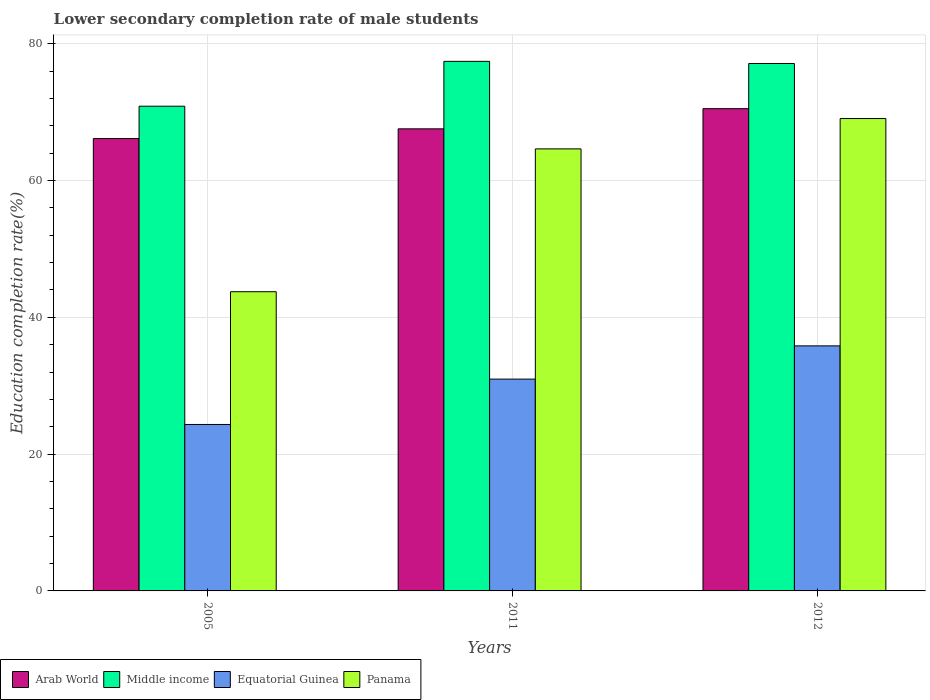How many different coloured bars are there?
Your answer should be very brief. 4. Are the number of bars on each tick of the X-axis equal?
Offer a very short reply. Yes. How many bars are there on the 2nd tick from the left?
Your answer should be very brief. 4. How many bars are there on the 3rd tick from the right?
Make the answer very short. 4. What is the label of the 2nd group of bars from the left?
Your answer should be very brief. 2011. What is the lower secondary completion rate of male students in Equatorial Guinea in 2012?
Provide a short and direct response. 35.83. Across all years, what is the maximum lower secondary completion rate of male students in Arab World?
Your response must be concise. 70.51. Across all years, what is the minimum lower secondary completion rate of male students in Panama?
Your response must be concise. 43.74. In which year was the lower secondary completion rate of male students in Arab World maximum?
Your answer should be compact. 2012. What is the total lower secondary completion rate of male students in Panama in the graph?
Keep it short and to the point. 177.43. What is the difference between the lower secondary completion rate of male students in Equatorial Guinea in 2005 and that in 2012?
Offer a terse response. -11.49. What is the difference between the lower secondary completion rate of male students in Equatorial Guinea in 2011 and the lower secondary completion rate of male students in Middle income in 2012?
Give a very brief answer. -46.14. What is the average lower secondary completion rate of male students in Arab World per year?
Provide a succinct answer. 68.07. In the year 2005, what is the difference between the lower secondary completion rate of male students in Middle income and lower secondary completion rate of male students in Arab World?
Provide a short and direct response. 4.73. What is the ratio of the lower secondary completion rate of male students in Arab World in 2005 to that in 2011?
Keep it short and to the point. 0.98. Is the lower secondary completion rate of male students in Middle income in 2011 less than that in 2012?
Provide a short and direct response. No. What is the difference between the highest and the second highest lower secondary completion rate of male students in Panama?
Offer a very short reply. 4.44. What is the difference between the highest and the lowest lower secondary completion rate of male students in Middle income?
Offer a very short reply. 6.56. In how many years, is the lower secondary completion rate of male students in Middle income greater than the average lower secondary completion rate of male students in Middle income taken over all years?
Provide a short and direct response. 2. Is the sum of the lower secondary completion rate of male students in Equatorial Guinea in 2011 and 2012 greater than the maximum lower secondary completion rate of male students in Middle income across all years?
Keep it short and to the point. No. Is it the case that in every year, the sum of the lower secondary completion rate of male students in Equatorial Guinea and lower secondary completion rate of male students in Panama is greater than the sum of lower secondary completion rate of male students in Middle income and lower secondary completion rate of male students in Arab World?
Your response must be concise. No. What does the 1st bar from the left in 2011 represents?
Make the answer very short. Arab World. What does the 3rd bar from the right in 2012 represents?
Offer a very short reply. Middle income. Is it the case that in every year, the sum of the lower secondary completion rate of male students in Middle income and lower secondary completion rate of male students in Equatorial Guinea is greater than the lower secondary completion rate of male students in Panama?
Your answer should be very brief. Yes. Are the values on the major ticks of Y-axis written in scientific E-notation?
Ensure brevity in your answer.  No. Does the graph contain grids?
Make the answer very short. Yes. Where does the legend appear in the graph?
Ensure brevity in your answer.  Bottom left. How many legend labels are there?
Make the answer very short. 4. What is the title of the graph?
Give a very brief answer. Lower secondary completion rate of male students. What is the label or title of the X-axis?
Your answer should be compact. Years. What is the label or title of the Y-axis?
Ensure brevity in your answer.  Education completion rate(%). What is the Education completion rate(%) in Arab World in 2005?
Ensure brevity in your answer.  66.14. What is the Education completion rate(%) in Middle income in 2005?
Your answer should be compact. 70.86. What is the Education completion rate(%) in Equatorial Guinea in 2005?
Ensure brevity in your answer.  24.33. What is the Education completion rate(%) of Panama in 2005?
Provide a succinct answer. 43.74. What is the Education completion rate(%) of Arab World in 2011?
Your answer should be compact. 67.56. What is the Education completion rate(%) in Middle income in 2011?
Give a very brief answer. 77.42. What is the Education completion rate(%) of Equatorial Guinea in 2011?
Keep it short and to the point. 30.97. What is the Education completion rate(%) in Panama in 2011?
Make the answer very short. 64.63. What is the Education completion rate(%) of Arab World in 2012?
Ensure brevity in your answer.  70.51. What is the Education completion rate(%) in Middle income in 2012?
Offer a very short reply. 77.11. What is the Education completion rate(%) of Equatorial Guinea in 2012?
Your answer should be very brief. 35.83. What is the Education completion rate(%) in Panama in 2012?
Ensure brevity in your answer.  69.06. Across all years, what is the maximum Education completion rate(%) of Arab World?
Your answer should be very brief. 70.51. Across all years, what is the maximum Education completion rate(%) in Middle income?
Ensure brevity in your answer.  77.42. Across all years, what is the maximum Education completion rate(%) in Equatorial Guinea?
Your answer should be very brief. 35.83. Across all years, what is the maximum Education completion rate(%) in Panama?
Offer a very short reply. 69.06. Across all years, what is the minimum Education completion rate(%) in Arab World?
Your answer should be very brief. 66.14. Across all years, what is the minimum Education completion rate(%) of Middle income?
Your answer should be compact. 70.86. Across all years, what is the minimum Education completion rate(%) in Equatorial Guinea?
Give a very brief answer. 24.33. Across all years, what is the minimum Education completion rate(%) of Panama?
Your response must be concise. 43.74. What is the total Education completion rate(%) of Arab World in the graph?
Ensure brevity in your answer.  204.2. What is the total Education completion rate(%) of Middle income in the graph?
Offer a very short reply. 225.4. What is the total Education completion rate(%) in Equatorial Guinea in the graph?
Provide a succinct answer. 91.13. What is the total Education completion rate(%) in Panama in the graph?
Provide a short and direct response. 177.43. What is the difference between the Education completion rate(%) in Arab World in 2005 and that in 2011?
Offer a very short reply. -1.42. What is the difference between the Education completion rate(%) of Middle income in 2005 and that in 2011?
Offer a very short reply. -6.56. What is the difference between the Education completion rate(%) in Equatorial Guinea in 2005 and that in 2011?
Make the answer very short. -6.63. What is the difference between the Education completion rate(%) in Panama in 2005 and that in 2011?
Ensure brevity in your answer.  -20.88. What is the difference between the Education completion rate(%) in Arab World in 2005 and that in 2012?
Provide a short and direct response. -4.37. What is the difference between the Education completion rate(%) in Middle income in 2005 and that in 2012?
Offer a very short reply. -6.25. What is the difference between the Education completion rate(%) in Equatorial Guinea in 2005 and that in 2012?
Offer a very short reply. -11.49. What is the difference between the Education completion rate(%) in Panama in 2005 and that in 2012?
Provide a short and direct response. -25.32. What is the difference between the Education completion rate(%) in Arab World in 2011 and that in 2012?
Keep it short and to the point. -2.95. What is the difference between the Education completion rate(%) of Middle income in 2011 and that in 2012?
Your response must be concise. 0.31. What is the difference between the Education completion rate(%) in Equatorial Guinea in 2011 and that in 2012?
Ensure brevity in your answer.  -4.86. What is the difference between the Education completion rate(%) in Panama in 2011 and that in 2012?
Provide a short and direct response. -4.44. What is the difference between the Education completion rate(%) of Arab World in 2005 and the Education completion rate(%) of Middle income in 2011?
Offer a very short reply. -11.28. What is the difference between the Education completion rate(%) of Arab World in 2005 and the Education completion rate(%) of Equatorial Guinea in 2011?
Provide a short and direct response. 35.17. What is the difference between the Education completion rate(%) in Arab World in 2005 and the Education completion rate(%) in Panama in 2011?
Ensure brevity in your answer.  1.51. What is the difference between the Education completion rate(%) in Middle income in 2005 and the Education completion rate(%) in Equatorial Guinea in 2011?
Offer a very short reply. 39.9. What is the difference between the Education completion rate(%) in Middle income in 2005 and the Education completion rate(%) in Panama in 2011?
Ensure brevity in your answer.  6.24. What is the difference between the Education completion rate(%) in Equatorial Guinea in 2005 and the Education completion rate(%) in Panama in 2011?
Keep it short and to the point. -40.29. What is the difference between the Education completion rate(%) in Arab World in 2005 and the Education completion rate(%) in Middle income in 2012?
Keep it short and to the point. -10.97. What is the difference between the Education completion rate(%) of Arab World in 2005 and the Education completion rate(%) of Equatorial Guinea in 2012?
Give a very brief answer. 30.31. What is the difference between the Education completion rate(%) in Arab World in 2005 and the Education completion rate(%) in Panama in 2012?
Give a very brief answer. -2.92. What is the difference between the Education completion rate(%) in Middle income in 2005 and the Education completion rate(%) in Equatorial Guinea in 2012?
Your answer should be very brief. 35.04. What is the difference between the Education completion rate(%) of Middle income in 2005 and the Education completion rate(%) of Panama in 2012?
Give a very brief answer. 1.8. What is the difference between the Education completion rate(%) of Equatorial Guinea in 2005 and the Education completion rate(%) of Panama in 2012?
Provide a succinct answer. -44.73. What is the difference between the Education completion rate(%) of Arab World in 2011 and the Education completion rate(%) of Middle income in 2012?
Your response must be concise. -9.55. What is the difference between the Education completion rate(%) of Arab World in 2011 and the Education completion rate(%) of Equatorial Guinea in 2012?
Offer a very short reply. 31.73. What is the difference between the Education completion rate(%) of Arab World in 2011 and the Education completion rate(%) of Panama in 2012?
Make the answer very short. -1.51. What is the difference between the Education completion rate(%) of Middle income in 2011 and the Education completion rate(%) of Equatorial Guinea in 2012?
Provide a short and direct response. 41.6. What is the difference between the Education completion rate(%) in Middle income in 2011 and the Education completion rate(%) in Panama in 2012?
Provide a short and direct response. 8.36. What is the difference between the Education completion rate(%) in Equatorial Guinea in 2011 and the Education completion rate(%) in Panama in 2012?
Provide a succinct answer. -38.1. What is the average Education completion rate(%) of Arab World per year?
Your answer should be very brief. 68.07. What is the average Education completion rate(%) of Middle income per year?
Offer a terse response. 75.13. What is the average Education completion rate(%) in Equatorial Guinea per year?
Provide a succinct answer. 30.38. What is the average Education completion rate(%) in Panama per year?
Offer a terse response. 59.14. In the year 2005, what is the difference between the Education completion rate(%) of Arab World and Education completion rate(%) of Middle income?
Your response must be concise. -4.73. In the year 2005, what is the difference between the Education completion rate(%) in Arab World and Education completion rate(%) in Equatorial Guinea?
Your response must be concise. 41.8. In the year 2005, what is the difference between the Education completion rate(%) in Arab World and Education completion rate(%) in Panama?
Offer a terse response. 22.39. In the year 2005, what is the difference between the Education completion rate(%) in Middle income and Education completion rate(%) in Equatorial Guinea?
Provide a short and direct response. 46.53. In the year 2005, what is the difference between the Education completion rate(%) of Middle income and Education completion rate(%) of Panama?
Your answer should be compact. 27.12. In the year 2005, what is the difference between the Education completion rate(%) of Equatorial Guinea and Education completion rate(%) of Panama?
Your response must be concise. -19.41. In the year 2011, what is the difference between the Education completion rate(%) in Arab World and Education completion rate(%) in Middle income?
Offer a terse response. -9.87. In the year 2011, what is the difference between the Education completion rate(%) of Arab World and Education completion rate(%) of Equatorial Guinea?
Offer a very short reply. 36.59. In the year 2011, what is the difference between the Education completion rate(%) of Arab World and Education completion rate(%) of Panama?
Provide a short and direct response. 2.93. In the year 2011, what is the difference between the Education completion rate(%) of Middle income and Education completion rate(%) of Equatorial Guinea?
Give a very brief answer. 46.46. In the year 2011, what is the difference between the Education completion rate(%) in Middle income and Education completion rate(%) in Panama?
Your response must be concise. 12.8. In the year 2011, what is the difference between the Education completion rate(%) of Equatorial Guinea and Education completion rate(%) of Panama?
Offer a terse response. -33.66. In the year 2012, what is the difference between the Education completion rate(%) in Arab World and Education completion rate(%) in Middle income?
Keep it short and to the point. -6.6. In the year 2012, what is the difference between the Education completion rate(%) of Arab World and Education completion rate(%) of Equatorial Guinea?
Ensure brevity in your answer.  34.68. In the year 2012, what is the difference between the Education completion rate(%) of Arab World and Education completion rate(%) of Panama?
Ensure brevity in your answer.  1.44. In the year 2012, what is the difference between the Education completion rate(%) in Middle income and Education completion rate(%) in Equatorial Guinea?
Your answer should be compact. 41.28. In the year 2012, what is the difference between the Education completion rate(%) in Middle income and Education completion rate(%) in Panama?
Make the answer very short. 8.05. In the year 2012, what is the difference between the Education completion rate(%) in Equatorial Guinea and Education completion rate(%) in Panama?
Your answer should be compact. -33.24. What is the ratio of the Education completion rate(%) of Arab World in 2005 to that in 2011?
Your answer should be compact. 0.98. What is the ratio of the Education completion rate(%) in Middle income in 2005 to that in 2011?
Provide a succinct answer. 0.92. What is the ratio of the Education completion rate(%) in Equatorial Guinea in 2005 to that in 2011?
Give a very brief answer. 0.79. What is the ratio of the Education completion rate(%) of Panama in 2005 to that in 2011?
Provide a succinct answer. 0.68. What is the ratio of the Education completion rate(%) of Arab World in 2005 to that in 2012?
Provide a succinct answer. 0.94. What is the ratio of the Education completion rate(%) of Middle income in 2005 to that in 2012?
Make the answer very short. 0.92. What is the ratio of the Education completion rate(%) of Equatorial Guinea in 2005 to that in 2012?
Provide a succinct answer. 0.68. What is the ratio of the Education completion rate(%) in Panama in 2005 to that in 2012?
Ensure brevity in your answer.  0.63. What is the ratio of the Education completion rate(%) in Arab World in 2011 to that in 2012?
Your response must be concise. 0.96. What is the ratio of the Education completion rate(%) of Equatorial Guinea in 2011 to that in 2012?
Ensure brevity in your answer.  0.86. What is the ratio of the Education completion rate(%) of Panama in 2011 to that in 2012?
Keep it short and to the point. 0.94. What is the difference between the highest and the second highest Education completion rate(%) in Arab World?
Offer a terse response. 2.95. What is the difference between the highest and the second highest Education completion rate(%) in Middle income?
Ensure brevity in your answer.  0.31. What is the difference between the highest and the second highest Education completion rate(%) in Equatorial Guinea?
Your response must be concise. 4.86. What is the difference between the highest and the second highest Education completion rate(%) of Panama?
Your answer should be compact. 4.44. What is the difference between the highest and the lowest Education completion rate(%) in Arab World?
Your answer should be very brief. 4.37. What is the difference between the highest and the lowest Education completion rate(%) in Middle income?
Ensure brevity in your answer.  6.56. What is the difference between the highest and the lowest Education completion rate(%) in Equatorial Guinea?
Keep it short and to the point. 11.49. What is the difference between the highest and the lowest Education completion rate(%) of Panama?
Provide a succinct answer. 25.32. 